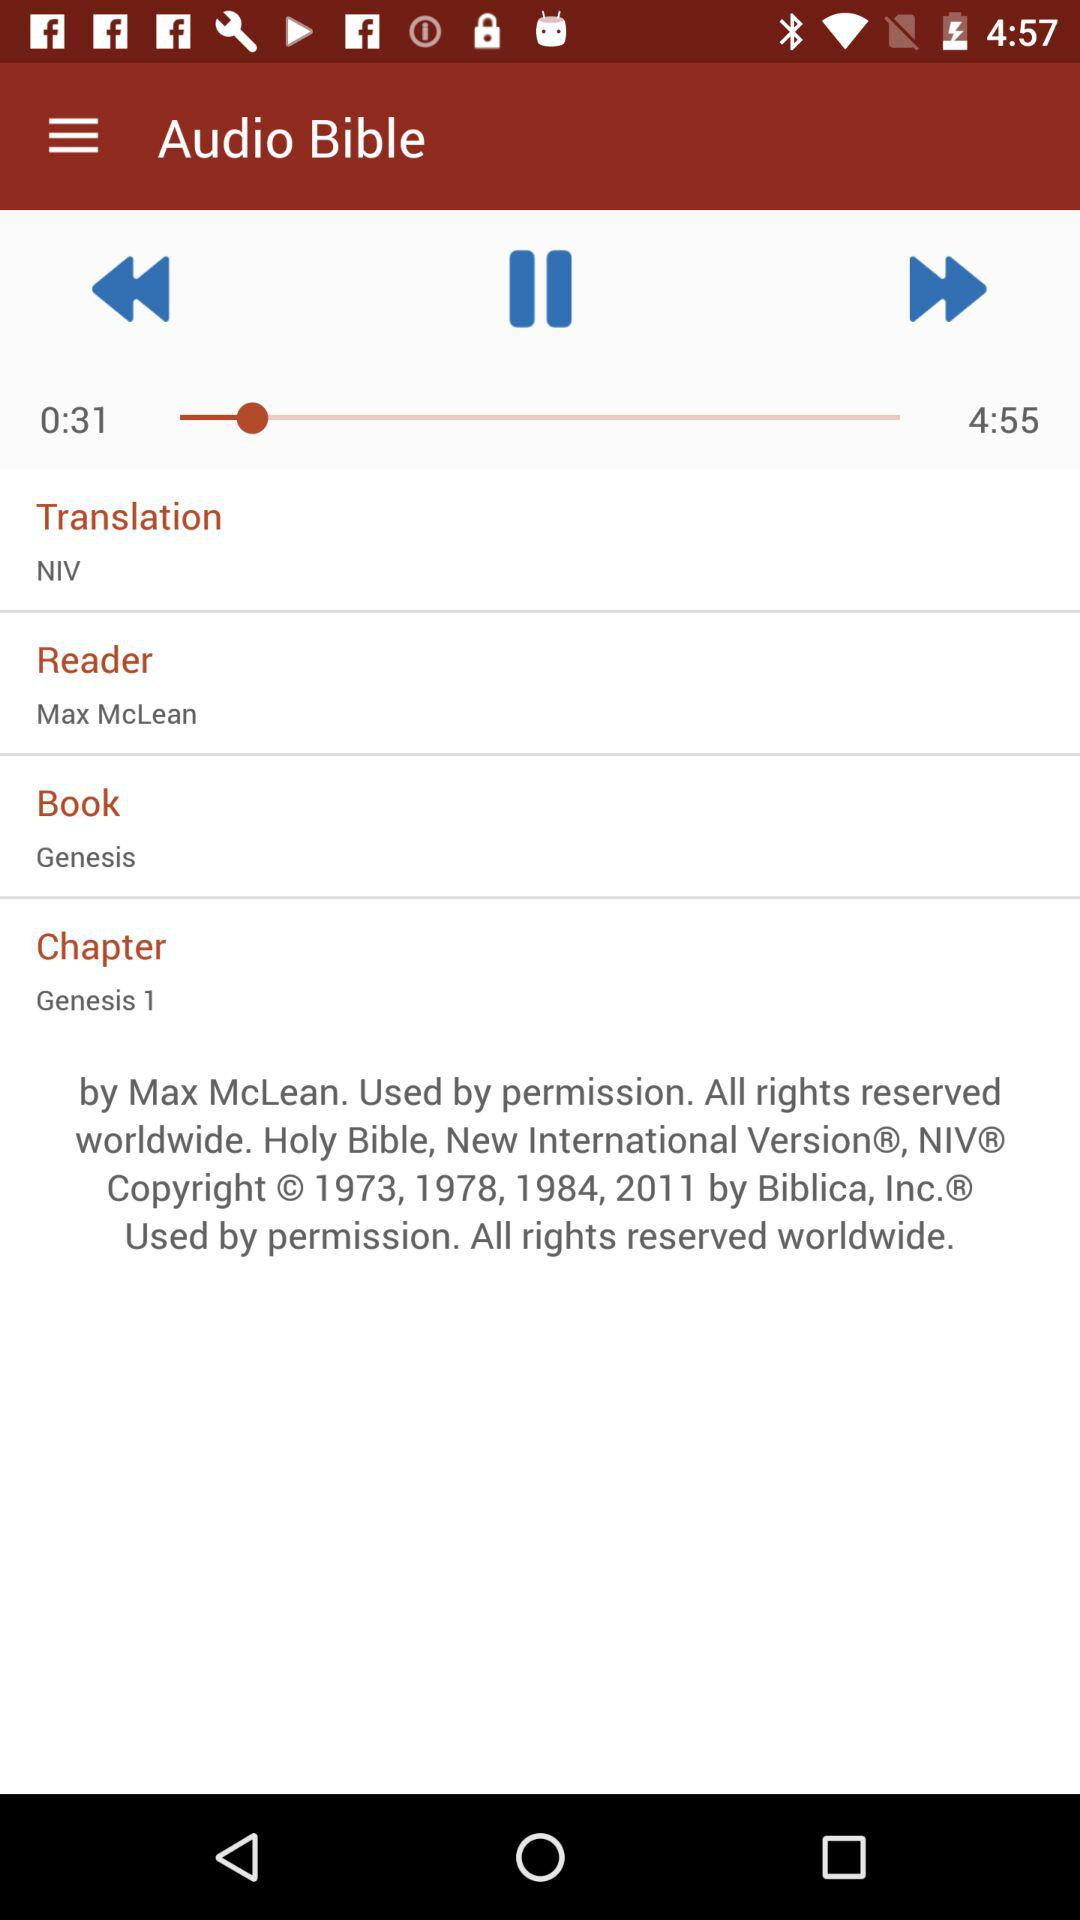Who is the reader? The reader is "Max McLean". 